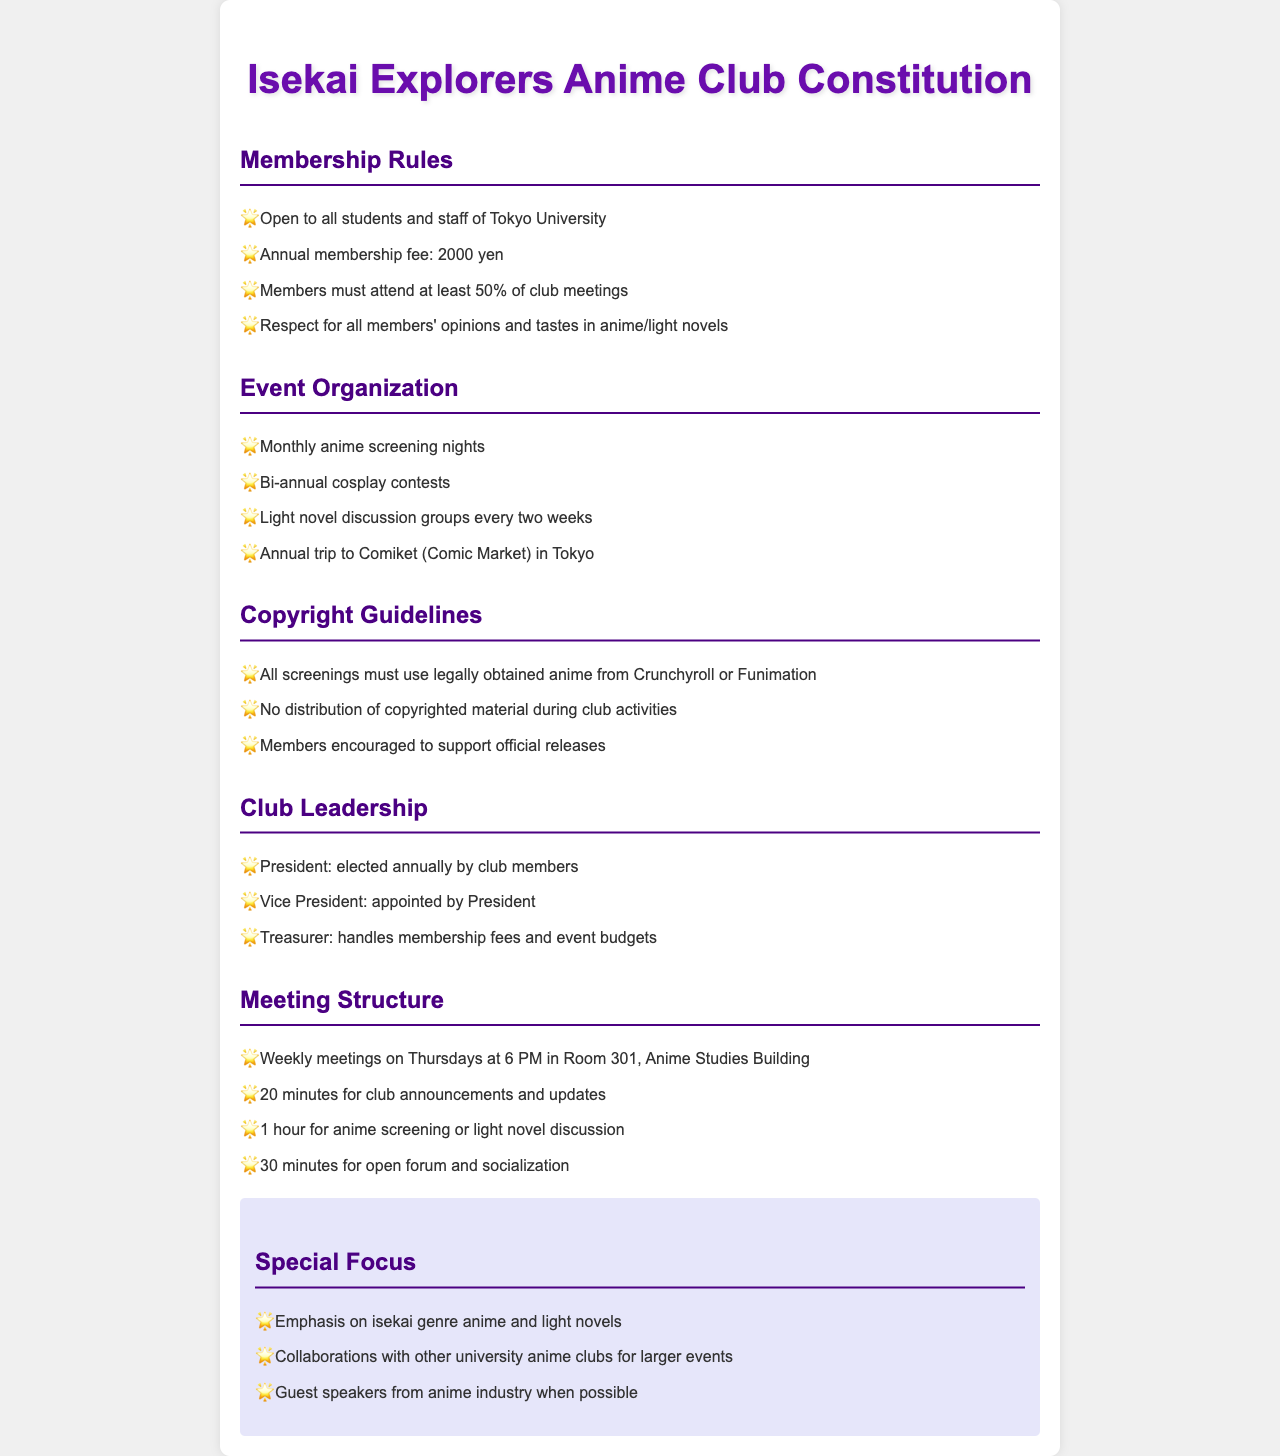What is the annual membership fee? The annual membership fee is specified in the membership rules section of the document.
Answer: 2000 yen How often does the anime screening night occur? The event organization section indicates the frequency of the anime screening nights.
Answer: Monthly What must members do to maintain their membership? The membership rules state the requirement for attending club meetings.
Answer: Attend at least 50% of meetings Where are the weekly meetings held? The meeting structure section provides the location for club meetings.
Answer: Room 301, Anime Studies Building What genre is emphasized in the club's special focus? The special focus section highlights the main genre the club is centered around.
Answer: Isekai Who is elected annually by club members? The club leadership section specifies who is elected on an annual basis.
Answer: President What is prohibited during club activities regarding copyrighted material? The copyright guidelines outline restrictions on dealings with copyrighted material.
Answer: No distribution How frequently are light novel discussion groups held? The event organization section mentions the frequency for light novel discussion groups.
Answer: Every two weeks What role is appointed by the President? The club leadership section describes roles within the club structure.
Answer: Vice President 